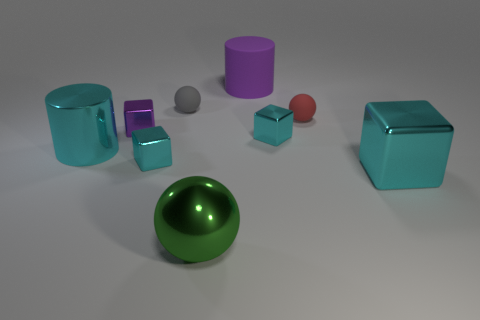Is there any pattern or uniformity to the arrangement of the objects in the image? The objects appear to be arranged without a specific pattern. They are placed at various distances and positions, which seems to be random rather than conforming to a discernible order or sequence. 